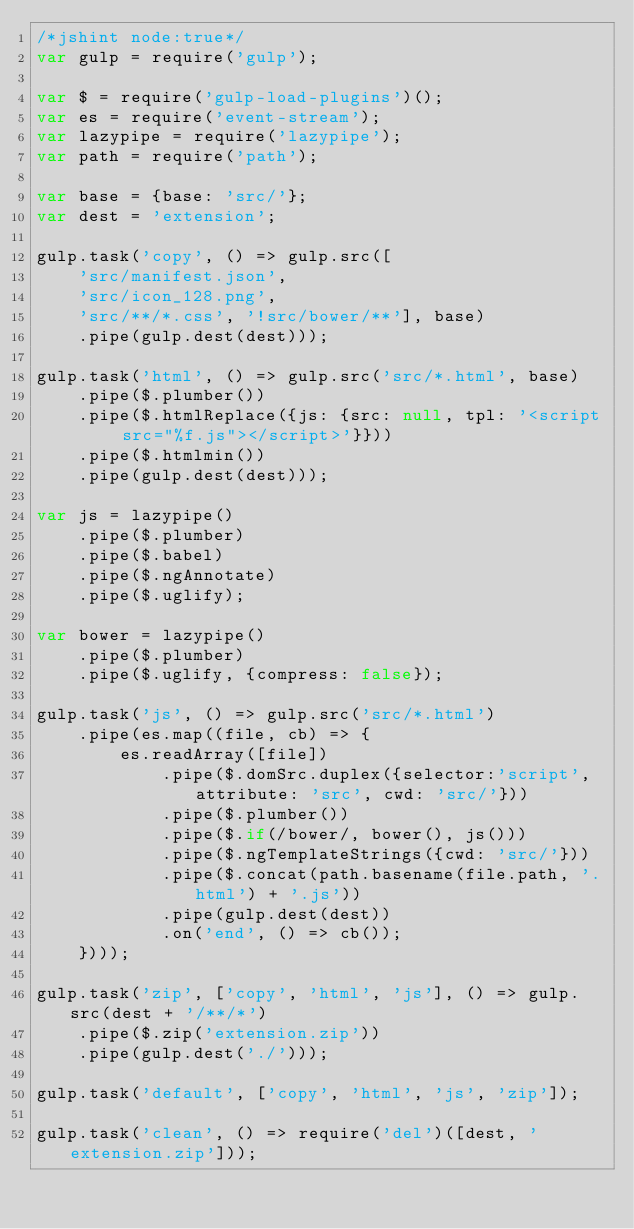<code> <loc_0><loc_0><loc_500><loc_500><_JavaScript_>/*jshint node:true*/
var gulp = require('gulp');

var $ = require('gulp-load-plugins')();
var es = require('event-stream');
var lazypipe = require('lazypipe');
var path = require('path');

var base = {base: 'src/'};
var dest = 'extension';

gulp.task('copy', () => gulp.src([
    'src/manifest.json',
    'src/icon_128.png',
    'src/**/*.css', '!src/bower/**'], base)
    .pipe(gulp.dest(dest)));

gulp.task('html', () => gulp.src('src/*.html', base)
    .pipe($.plumber())
    .pipe($.htmlReplace({js: {src: null, tpl: '<script src="%f.js"></script>'}}))
    .pipe($.htmlmin())
    .pipe(gulp.dest(dest)));

var js = lazypipe()
    .pipe($.plumber)
    .pipe($.babel)
    .pipe($.ngAnnotate)
    .pipe($.uglify);

var bower = lazypipe()
    .pipe($.plumber)
    .pipe($.uglify, {compress: false});

gulp.task('js', () => gulp.src('src/*.html')
    .pipe(es.map((file, cb) => {
        es.readArray([file])
            .pipe($.domSrc.duplex({selector:'script', attribute: 'src', cwd: 'src/'}))
            .pipe($.plumber())
            .pipe($.if(/bower/, bower(), js()))
            .pipe($.ngTemplateStrings({cwd: 'src/'}))
            .pipe($.concat(path.basename(file.path, '.html') + '.js'))
            .pipe(gulp.dest(dest))
            .on('end', () => cb());
    })));

gulp.task('zip', ['copy', 'html', 'js'], () => gulp.src(dest + '/**/*')
    .pipe($.zip('extension.zip'))
    .pipe(gulp.dest('./')));

gulp.task('default', ['copy', 'html', 'js', 'zip']);

gulp.task('clean', () => require('del')([dest, 'extension.zip']));
</code> 